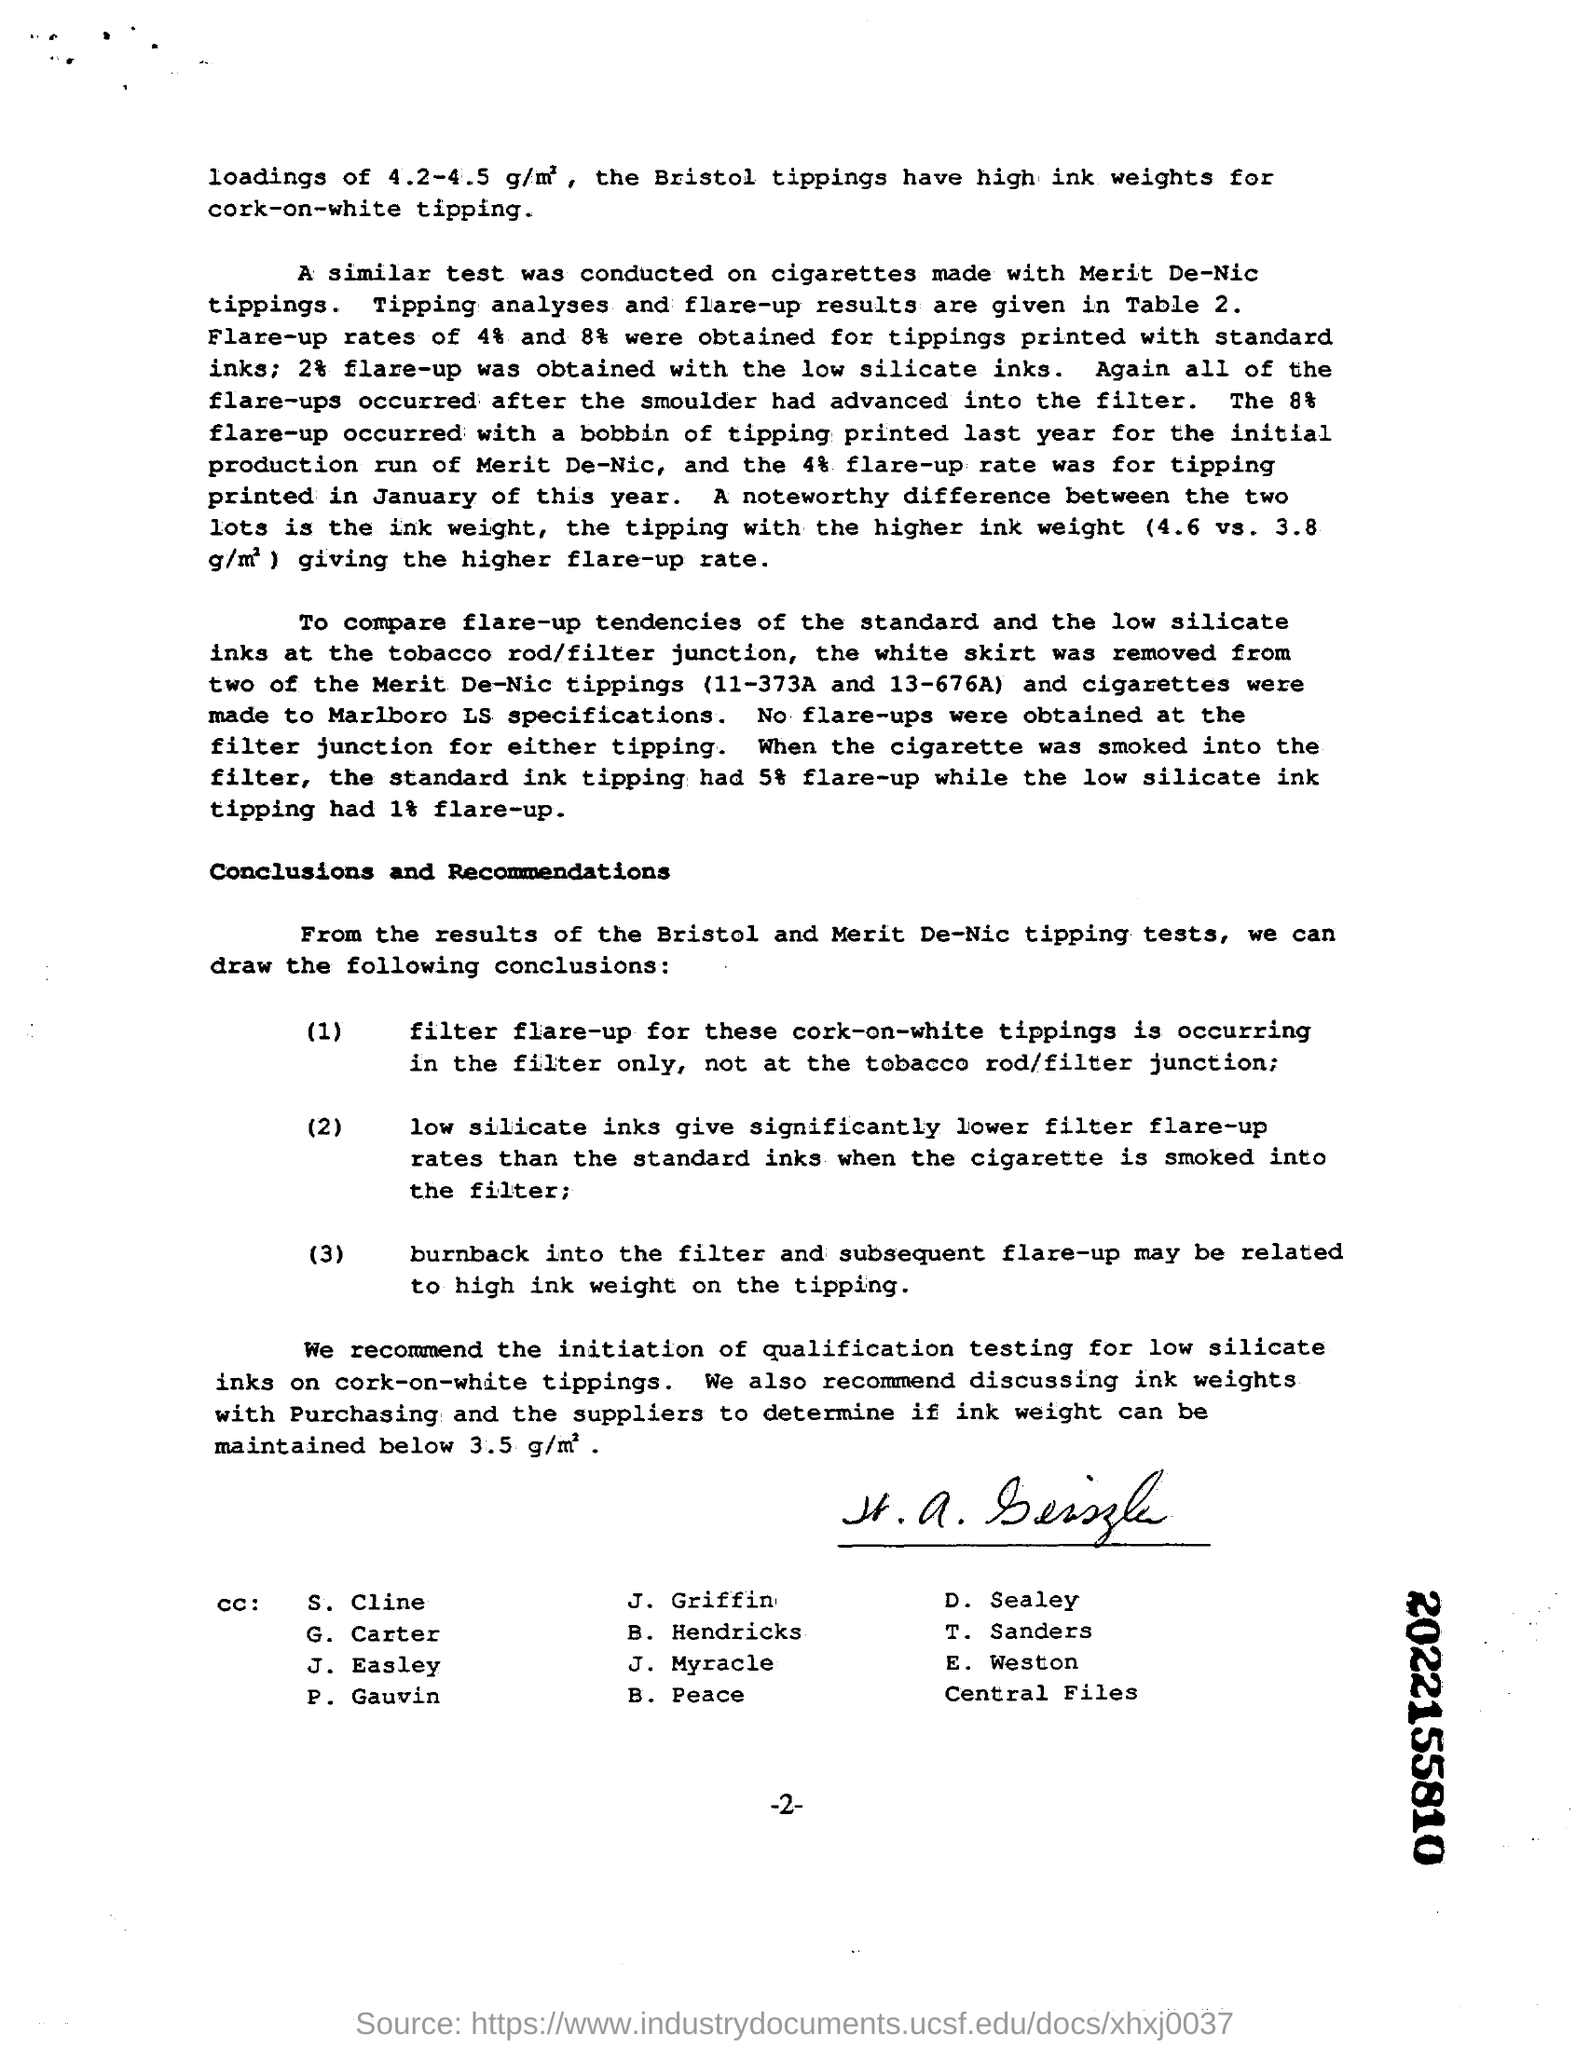Identify some key points in this picture. Low silicate inks have been shown to significantly reduce filter flare-up rates. Bristol tippings are made with high ink weights for the purpose of creating cork-on-white tipping. When a cigarette was smoked until the filter, the flare-up rate for the low silicate ink tipping was 1%, while the flare-up rate for the standard ink tipping was 5%. I have observed a written number on a piece of paper, which appears to be 10 digits long and written in bold font. The exact number is 2022155810. 